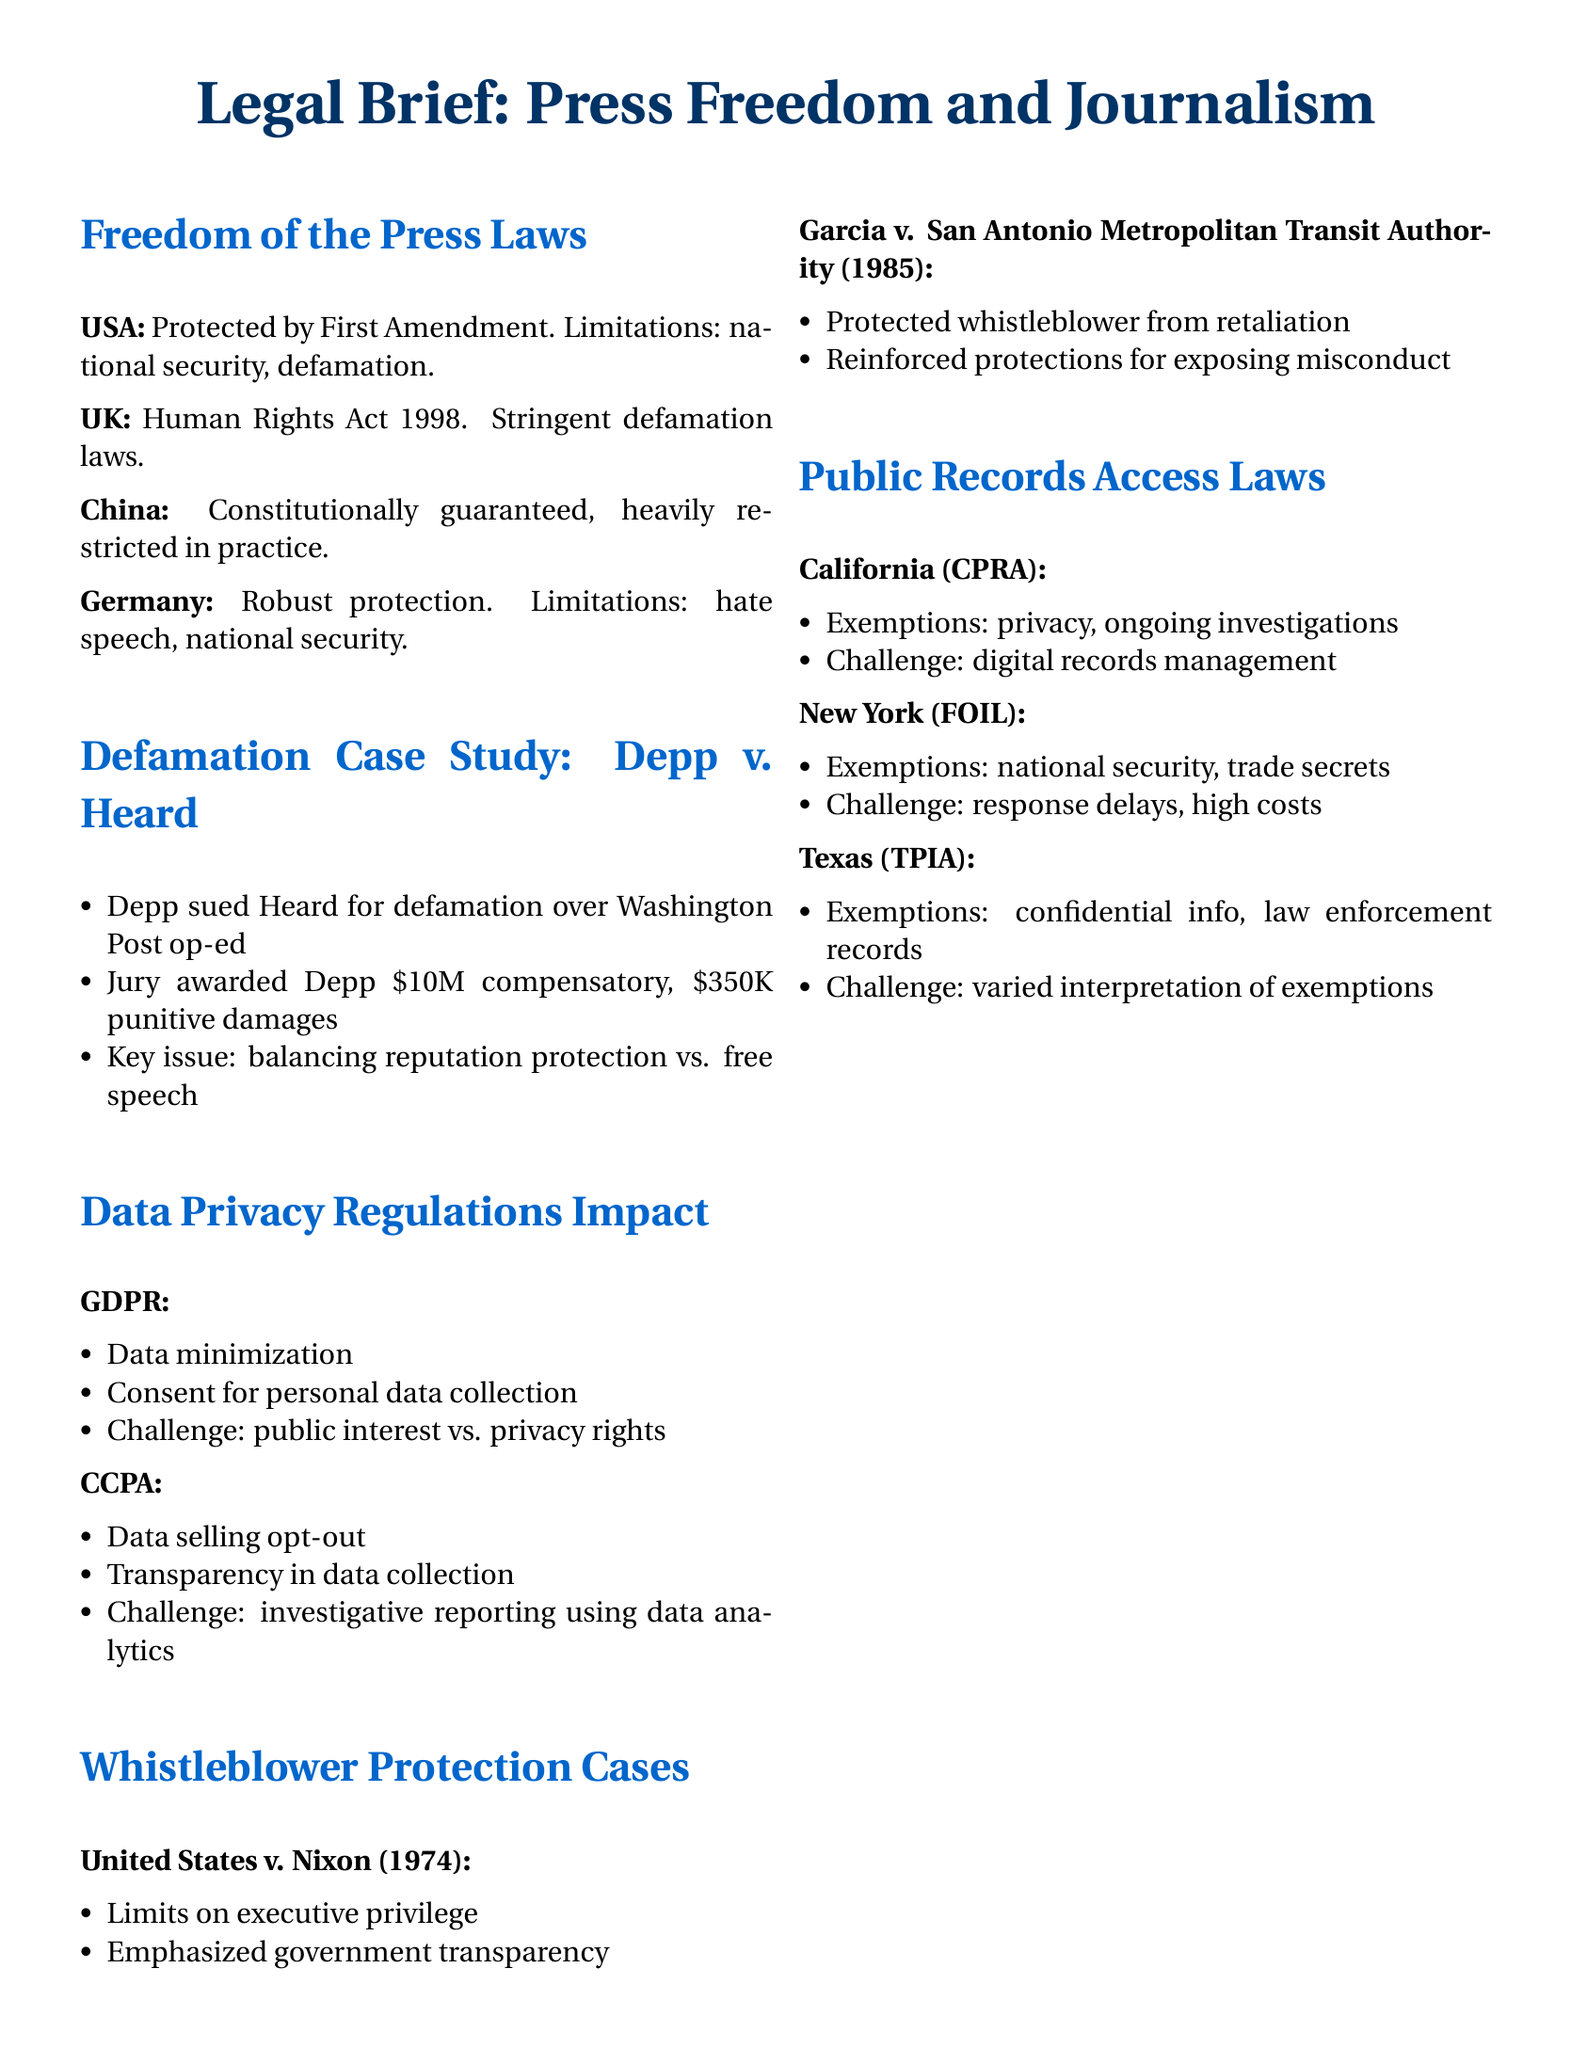What protections does the First Amendment provide? The First Amendment provides protection for freedom of the press in the USA.
Answer: freedom of the press What damages were awarded to Depp in the defamation case? The jury awarded Depp $10M compensatory and $350K punitive damages in the Depp v. Heard case.
Answer: $10M compensatory, $350K punitive What is a major challenge presented by the GDPR for journalists? A major challenge presented by the GDPR is balancing public interest and privacy rights.
Answer: public interest vs. privacy rights What legal case emphasized government transparency in whistleblower protections? The United States v. Nixon case emphasized limits on executive privilege and government transparency.
Answer: United States v. Nixon What are common exemptions for public records in California? Common exemptions for public records in California include privacy and ongoing investigations.
Answer: privacy, ongoing investigations What governing act protects freedom of the press in the UK? The Human Rights Act 1998 governs the protection of freedom of the press in the UK.
Answer: Human Rights Act 1998 Which legal principle was reinforced in Garcia v. San Antonio Metropolitan Transit Authority? The legal principle of protecting whistleblowers from retaliation was reinforced in Garcia v. San Antonio Metropolitan Transit Authority.
Answer: protecting from retaliation What is the exemption cited for public records in Texas? The exemption cited for public records in Texas includes confidential information and law enforcement records.
Answer: confidential info, law enforcement records 